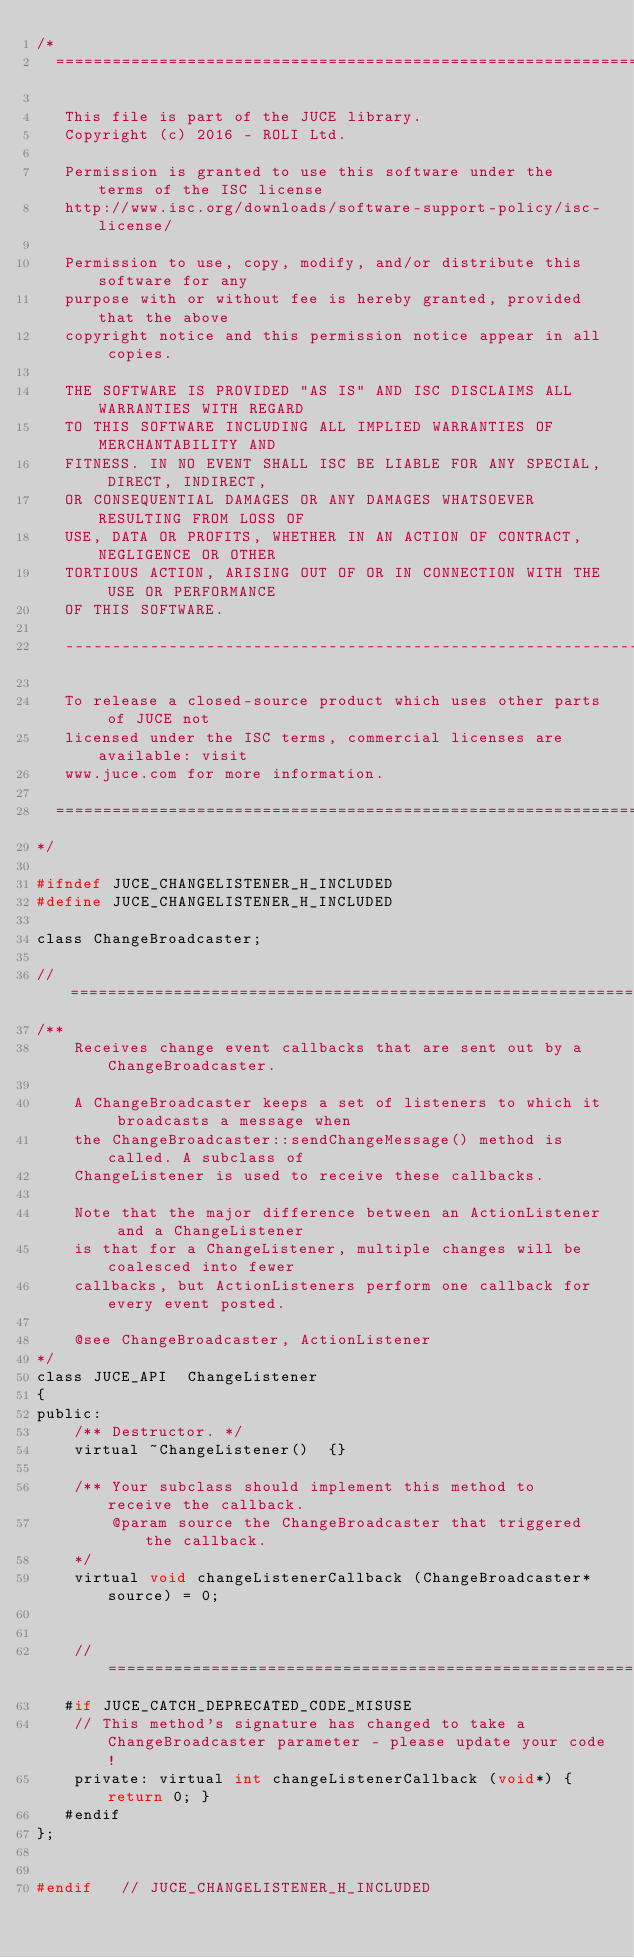Convert code to text. <code><loc_0><loc_0><loc_500><loc_500><_C_>/*
  ==============================================================================

   This file is part of the JUCE library.
   Copyright (c) 2016 - ROLI Ltd.

   Permission is granted to use this software under the terms of the ISC license
   http://www.isc.org/downloads/software-support-policy/isc-license/

   Permission to use, copy, modify, and/or distribute this software for any
   purpose with or without fee is hereby granted, provided that the above
   copyright notice and this permission notice appear in all copies.

   THE SOFTWARE IS PROVIDED "AS IS" AND ISC DISCLAIMS ALL WARRANTIES WITH REGARD
   TO THIS SOFTWARE INCLUDING ALL IMPLIED WARRANTIES OF MERCHANTABILITY AND
   FITNESS. IN NO EVENT SHALL ISC BE LIABLE FOR ANY SPECIAL, DIRECT, INDIRECT,
   OR CONSEQUENTIAL DAMAGES OR ANY DAMAGES WHATSOEVER RESULTING FROM LOSS OF
   USE, DATA OR PROFITS, WHETHER IN AN ACTION OF CONTRACT, NEGLIGENCE OR OTHER
   TORTIOUS ACTION, ARISING OUT OF OR IN CONNECTION WITH THE USE OR PERFORMANCE
   OF THIS SOFTWARE.

   -----------------------------------------------------------------------------

   To release a closed-source product which uses other parts of JUCE not
   licensed under the ISC terms, commercial licenses are available: visit
   www.juce.com for more information.

  ==============================================================================
*/

#ifndef JUCE_CHANGELISTENER_H_INCLUDED
#define JUCE_CHANGELISTENER_H_INCLUDED

class ChangeBroadcaster;

//==============================================================================
/**
    Receives change event callbacks that are sent out by a ChangeBroadcaster.

    A ChangeBroadcaster keeps a set of listeners to which it broadcasts a message when
    the ChangeBroadcaster::sendChangeMessage() method is called. A subclass of
    ChangeListener is used to receive these callbacks.

    Note that the major difference between an ActionListener and a ChangeListener
    is that for a ChangeListener, multiple changes will be coalesced into fewer
    callbacks, but ActionListeners perform one callback for every event posted.

    @see ChangeBroadcaster, ActionListener
*/
class JUCE_API  ChangeListener
{
public:
    /** Destructor. */
    virtual ~ChangeListener()  {}

    /** Your subclass should implement this method to receive the callback.
        @param source the ChangeBroadcaster that triggered the callback.
    */
    virtual void changeListenerCallback (ChangeBroadcaster* source) = 0;


    //==============================================================================
   #if JUCE_CATCH_DEPRECATED_CODE_MISUSE
    // This method's signature has changed to take a ChangeBroadcaster parameter - please update your code!
    private: virtual int changeListenerCallback (void*) { return 0; }
   #endif
};


#endif   // JUCE_CHANGELISTENER_H_INCLUDED
</code> 